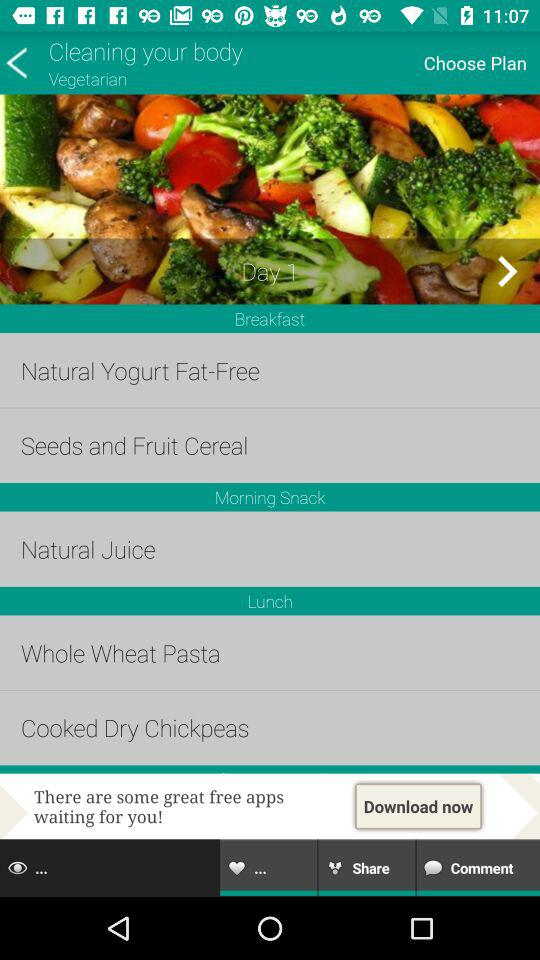How many days are there in this plan?
Answer the question using a single word or phrase. 1 